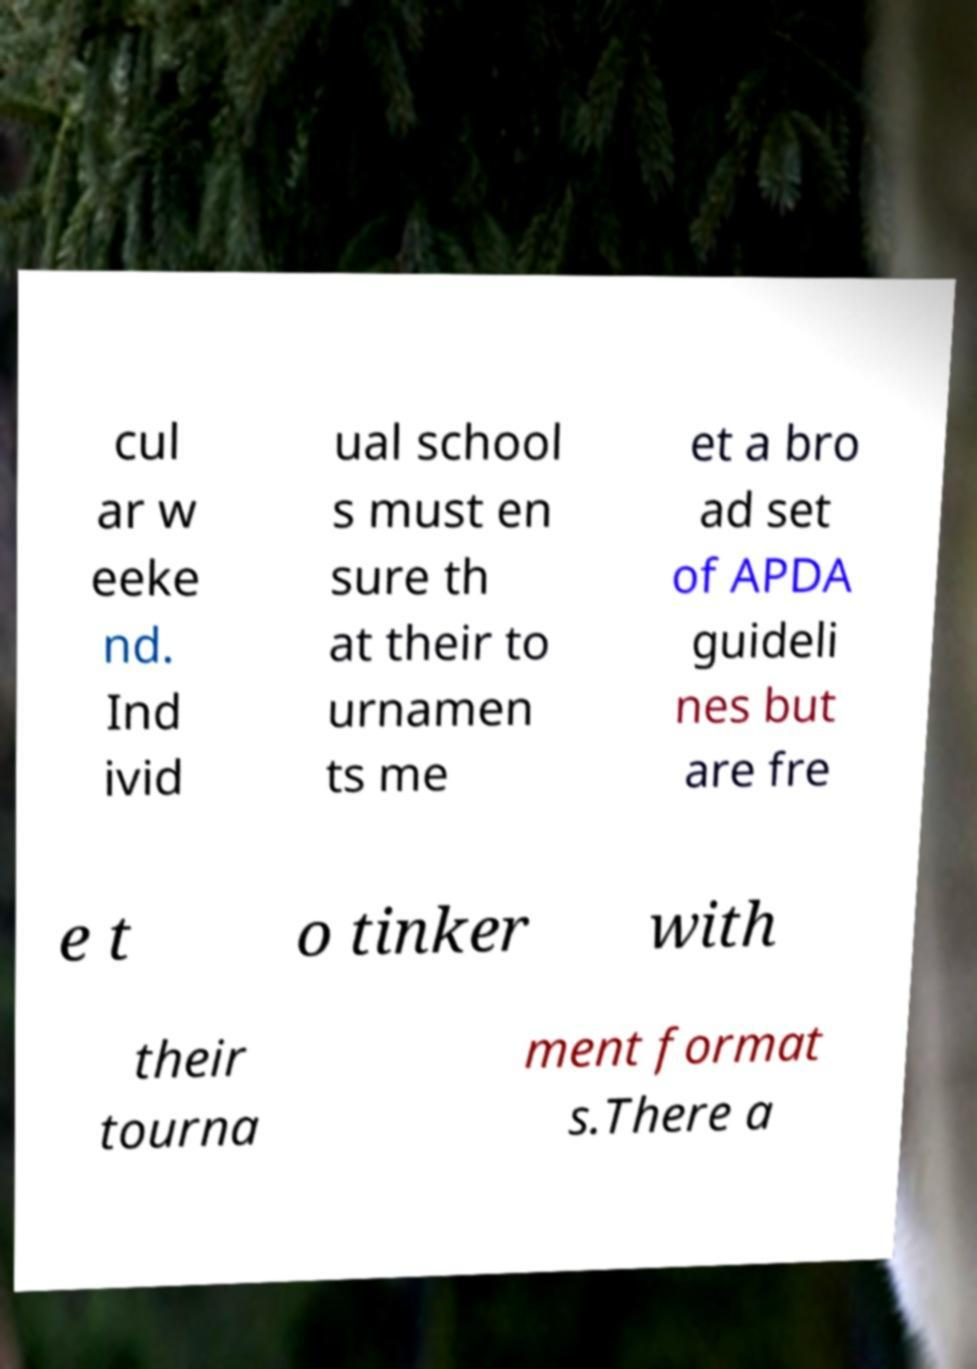Please identify and transcribe the text found in this image. cul ar w eeke nd. Ind ivid ual school s must en sure th at their to urnamen ts me et a bro ad set of APDA guideli nes but are fre e t o tinker with their tourna ment format s.There a 